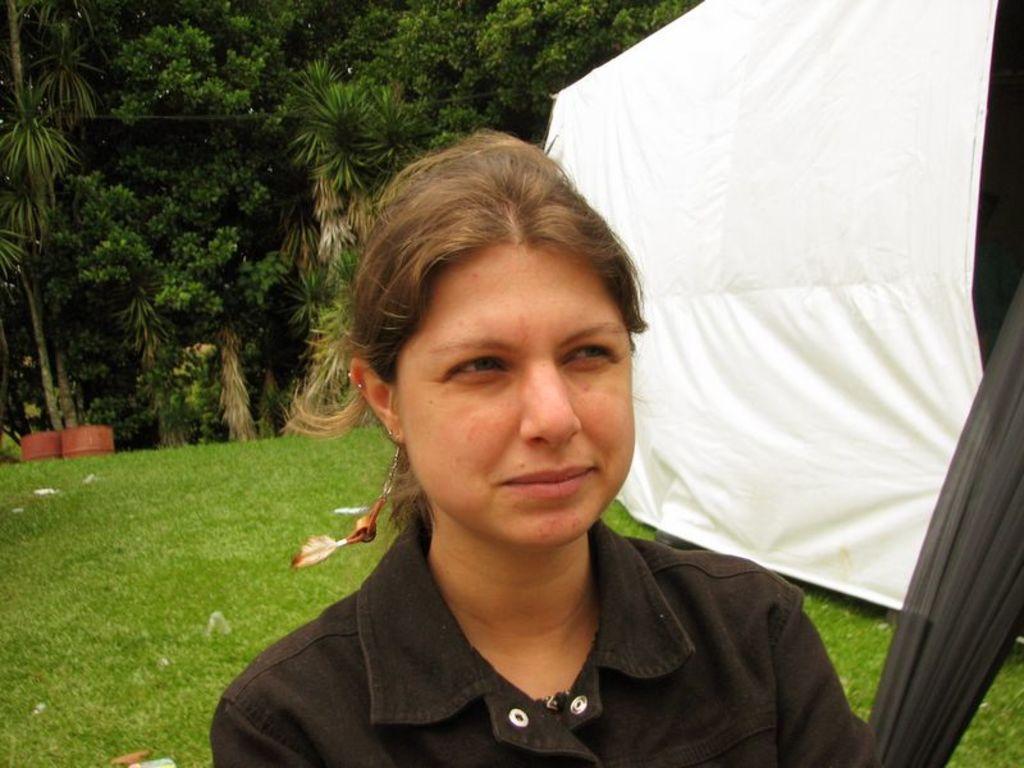Describe this image in one or two sentences. This picture is clicked outside. In the foreground there is a person wearing black color shirt and the seems to be standing on the ground. In the background we can see the green grass, plants, trees and a white color tint. 